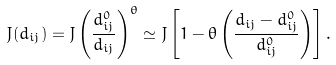Convert formula to latex. <formula><loc_0><loc_0><loc_500><loc_500>J ( d _ { i j } ) = J \left ( \frac { d _ { i j } ^ { 0 } } { d _ { i j } } \right ) ^ { \theta } \simeq J \left [ 1 - \theta \left ( \frac { d _ { i j } - d _ { i j } ^ { 0 } } { d _ { i j } ^ { 0 } } \right ) \right ] .</formula> 